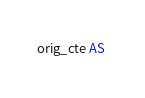<code> <loc_0><loc_0><loc_500><loc_500><_SQL_>orig_cte AS </code> 